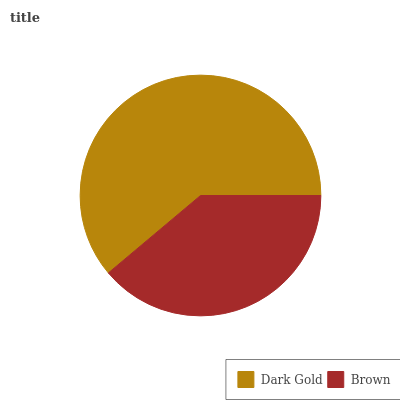Is Brown the minimum?
Answer yes or no. Yes. Is Dark Gold the maximum?
Answer yes or no. Yes. Is Brown the maximum?
Answer yes or no. No. Is Dark Gold greater than Brown?
Answer yes or no. Yes. Is Brown less than Dark Gold?
Answer yes or no. Yes. Is Brown greater than Dark Gold?
Answer yes or no. No. Is Dark Gold less than Brown?
Answer yes or no. No. Is Dark Gold the high median?
Answer yes or no. Yes. Is Brown the low median?
Answer yes or no. Yes. Is Brown the high median?
Answer yes or no. No. Is Dark Gold the low median?
Answer yes or no. No. 